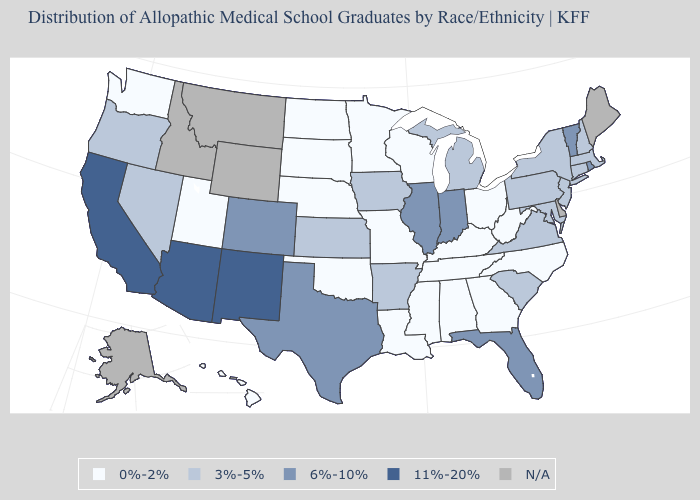Name the states that have a value in the range 0%-2%?
Short answer required. Alabama, Georgia, Hawaii, Kentucky, Louisiana, Minnesota, Mississippi, Missouri, Nebraska, North Carolina, North Dakota, Ohio, Oklahoma, South Dakota, Tennessee, Utah, Washington, West Virginia, Wisconsin. Does New Mexico have the highest value in the West?
Quick response, please. Yes. Is the legend a continuous bar?
Write a very short answer. No. Among the states that border California , does Arizona have the highest value?
Quick response, please. Yes. Name the states that have a value in the range 11%-20%?
Short answer required. Arizona, California, New Mexico. Among the states that border Oregon , which have the highest value?
Write a very short answer. California. What is the lowest value in the South?
Answer briefly. 0%-2%. What is the value of Arizona?
Write a very short answer. 11%-20%. What is the lowest value in the Northeast?
Give a very brief answer. 3%-5%. What is the value of New Jersey?
Quick response, please. 3%-5%. Does Florida have the highest value in the South?
Short answer required. Yes. Which states hav the highest value in the West?
Answer briefly. Arizona, California, New Mexico. What is the lowest value in the USA?
Short answer required. 0%-2%. What is the value of Kansas?
Answer briefly. 3%-5%. What is the value of South Carolina?
Keep it brief. 3%-5%. 